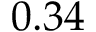<formula> <loc_0><loc_0><loc_500><loc_500>0 . 3 4</formula> 